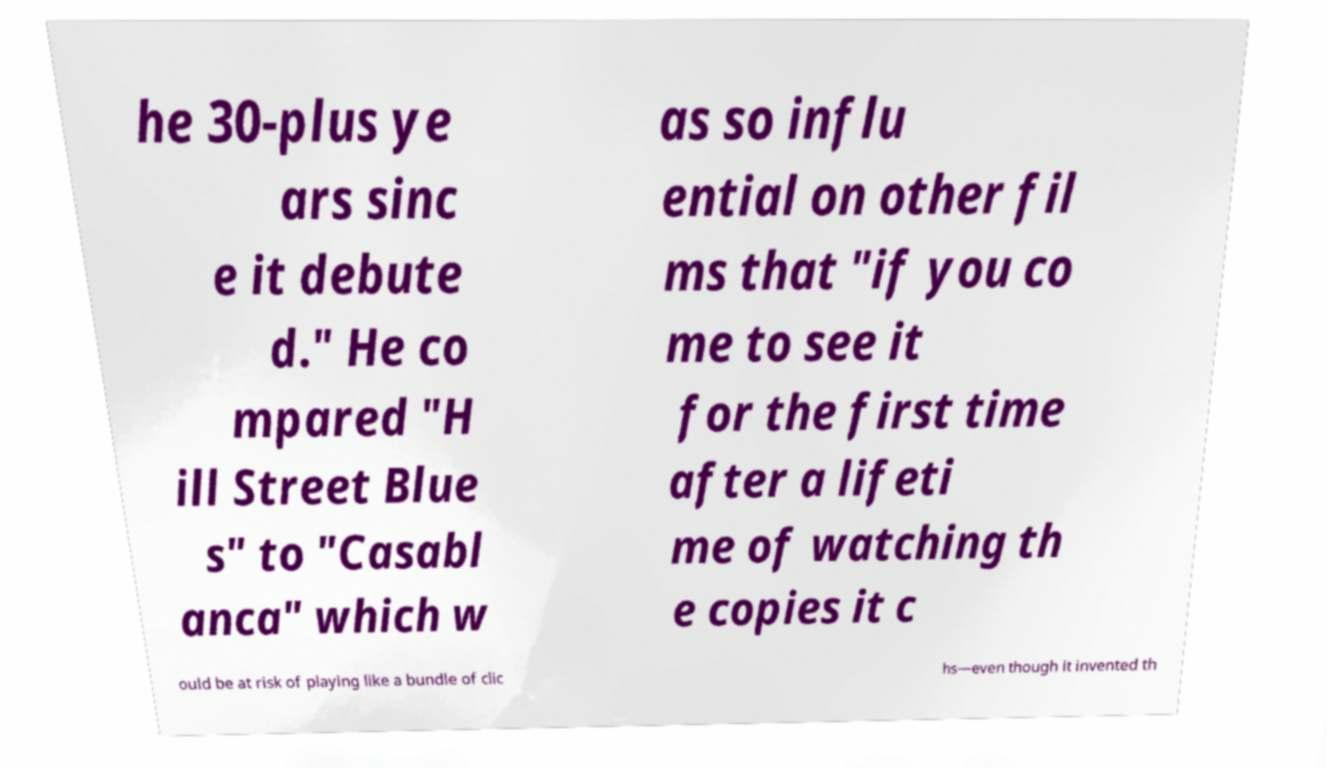For documentation purposes, I need the text within this image transcribed. Could you provide that? he 30-plus ye ars sinc e it debute d." He co mpared "H ill Street Blue s" to "Casabl anca" which w as so influ ential on other fil ms that "if you co me to see it for the first time after a lifeti me of watching th e copies it c ould be at risk of playing like a bundle of clic hs—even though it invented th 